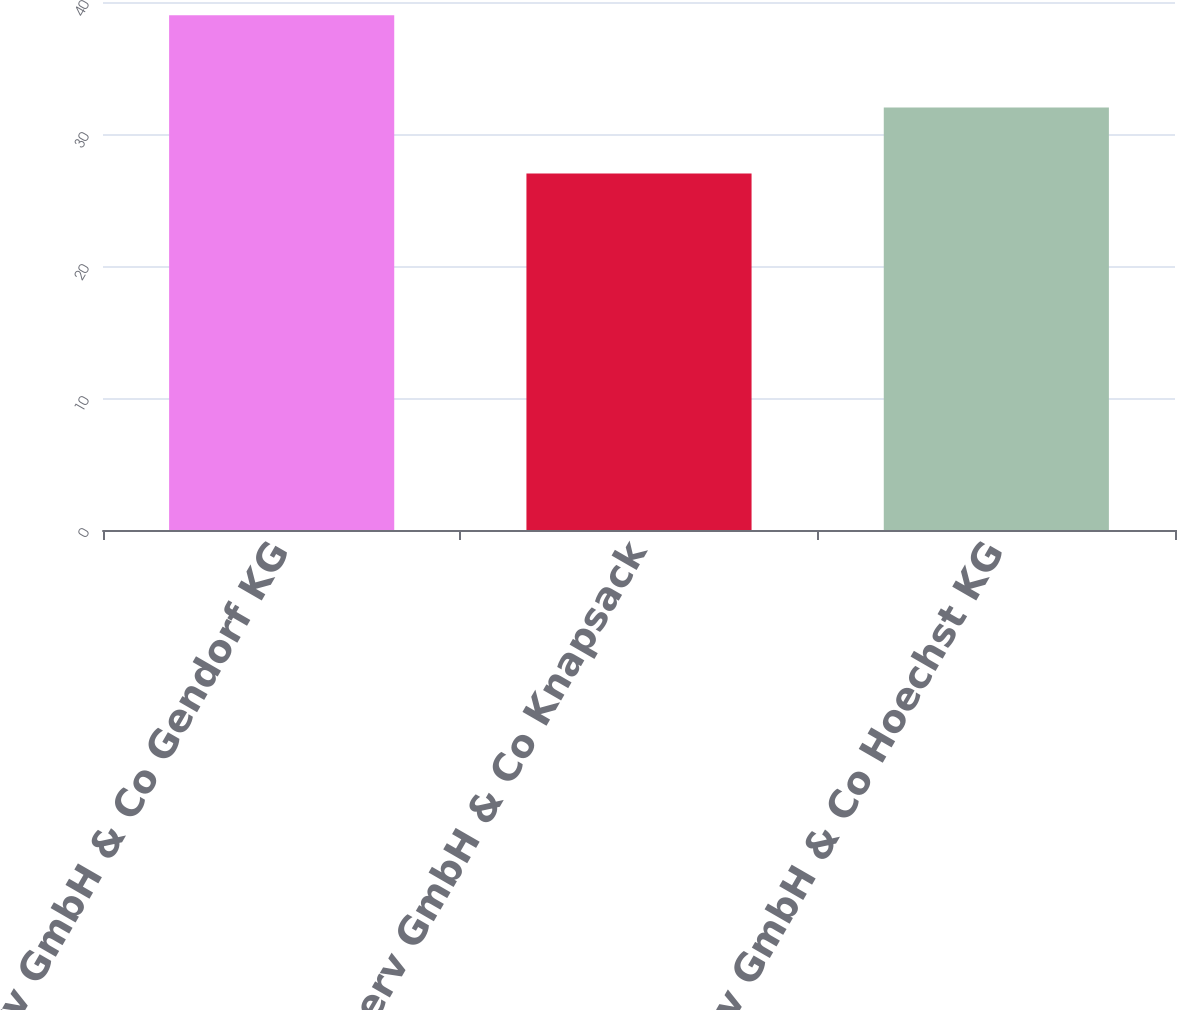Convert chart to OTSL. <chart><loc_0><loc_0><loc_500><loc_500><bar_chart><fcel>InfraServ GmbH & Co Gendorf KG<fcel>InfraServ GmbH & Co Knapsack<fcel>InfraServ GmbH & Co Hoechst KG<nl><fcel>39<fcel>27<fcel>32<nl></chart> 